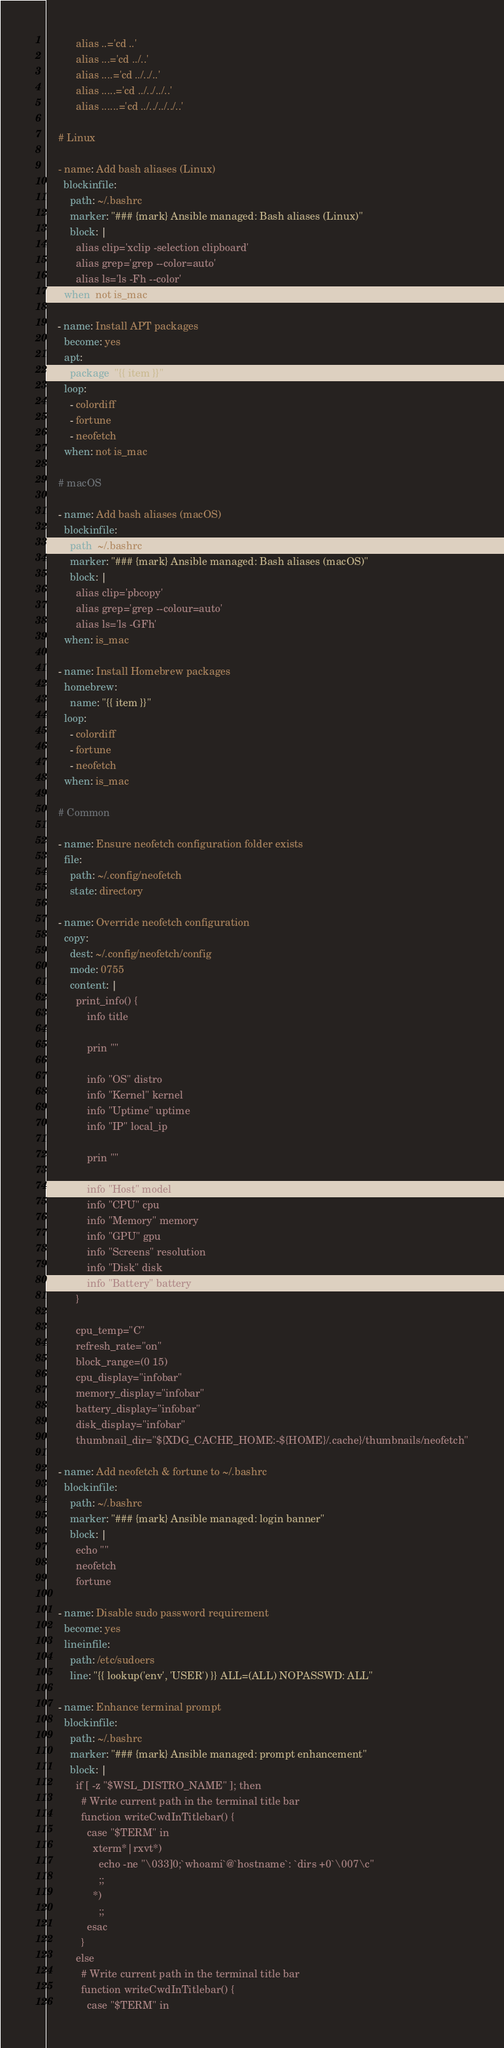<code> <loc_0><loc_0><loc_500><loc_500><_YAML_>          alias ..='cd ..'
          alias ...='cd ../..'
          alias ....='cd ../../..'
          alias .....='cd ../../../..'
          alias ......='cd ../../../../..'

    # Linux

    - name: Add bash aliases (Linux)
      blockinfile:
        path: ~/.bashrc
        marker: "### {mark} Ansible managed: Bash aliases (Linux)"
        block: |
          alias clip='xclip -selection clipboard'
          alias grep='grep --color=auto'
          alias ls='ls -Fh --color'
      when: not is_mac

    - name: Install APT packages
      become: yes
      apt:
        package: "{{ item }}"
      loop:
        - colordiff
        - fortune
        - neofetch
      when: not is_mac

    # macOS

    - name: Add bash aliases (macOS)
      blockinfile:
        path: ~/.bashrc
        marker: "### {mark} Ansible managed: Bash aliases (macOS)"
        block: |
          alias clip='pbcopy'
          alias grep='grep --colour=auto'
          alias ls='ls -GFh'
      when: is_mac

    - name: Install Homebrew packages
      homebrew:
        name: "{{ item }}"
      loop:
        - colordiff
        - fortune
        - neofetch
      when: is_mac

    # Common

    - name: Ensure neofetch configuration folder exists
      file:
        path: ~/.config/neofetch
        state: directory

    - name: Override neofetch configuration
      copy:
        dest: ~/.config/neofetch/config
        mode: 0755
        content: |
          print_info() {
              info title

              prin ""

              info "OS" distro
              info "Kernel" kernel
              info "Uptime" uptime
              info "IP" local_ip

              prin ""

              info "Host" model
              info "CPU" cpu
              info "Memory" memory
              info "GPU" gpu
              info "Screens" resolution
              info "Disk" disk
              info "Battery" battery
          }

          cpu_temp="C"
          refresh_rate="on"
          block_range=(0 15)
          cpu_display="infobar"
          memory_display="infobar"
          battery_display="infobar"
          disk_display="infobar"
          thumbnail_dir="${XDG_CACHE_HOME:-${HOME}/.cache}/thumbnails/neofetch"

    - name: Add neofetch & fortune to ~/.bashrc
      blockinfile:
        path: ~/.bashrc
        marker: "### {mark} Ansible managed: login banner"
        block: |
          echo ""
          neofetch
          fortune

    - name: Disable sudo password requirement
      become: yes
      lineinfile:
        path: /etc/sudoers
        line: "{{ lookup('env', 'USER') }} ALL=(ALL) NOPASSWD: ALL"

    - name: Enhance terminal prompt
      blockinfile:
        path: ~/.bashrc
        marker: "### {mark} Ansible managed: prompt enhancement"
        block: |
          if [ -z "$WSL_DISTRO_NAME" ]; then
            # Write current path in the terminal title bar
            function writeCwdInTitlebar() {
              case "$TERM" in
                xterm*|rxvt*)
                  echo -ne "\033]0;`whoami`@`hostname`: `dirs +0`\007\c"
                  ;;
                *)
                  ;;
              esac
            }
          else
            # Write current path in the terminal title bar
            function writeCwdInTitlebar() {
              case "$TERM" in</code> 